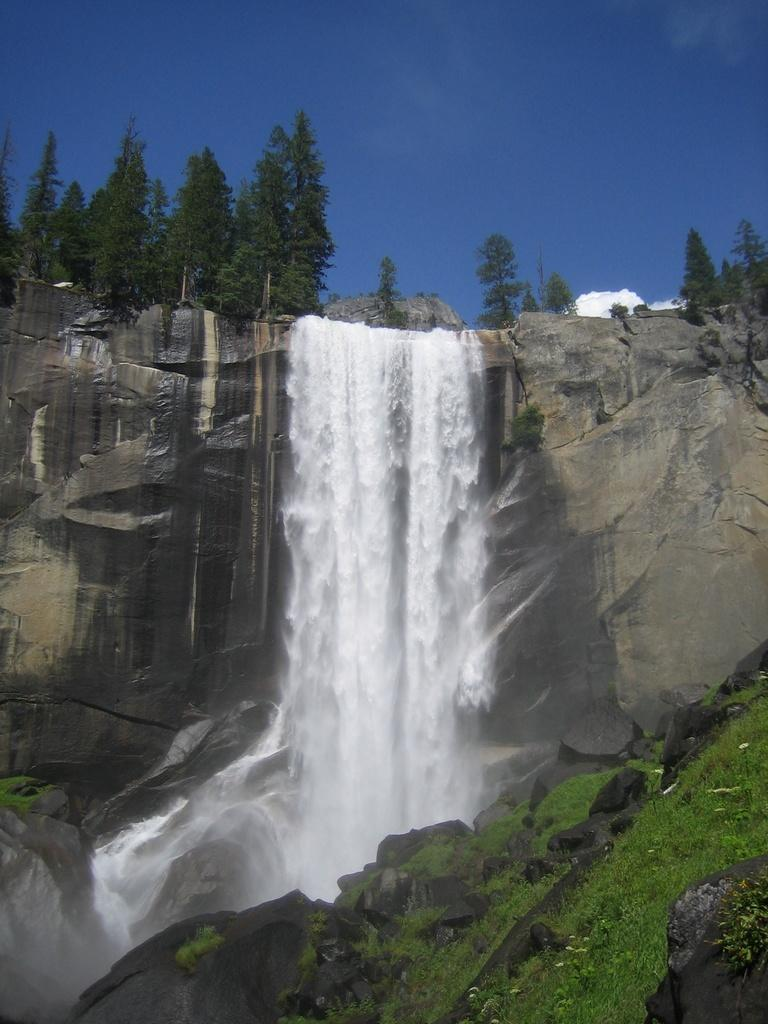What natural feature is the main subject of the image? There is a waterfall in the image. What can be seen on the right side of the image? There are rocks and grass on the right side of the image. What type of vegetation is at the top of the image? There are trees at the top of the image. What is visible at the top of the image besides the trees? The sky is visible at the top of the image. How many birds are in the flock flying over the waterfall in the image? There is no flock of birds present in the image; it features a waterfall, rocks, grass, trees, and the sky. 